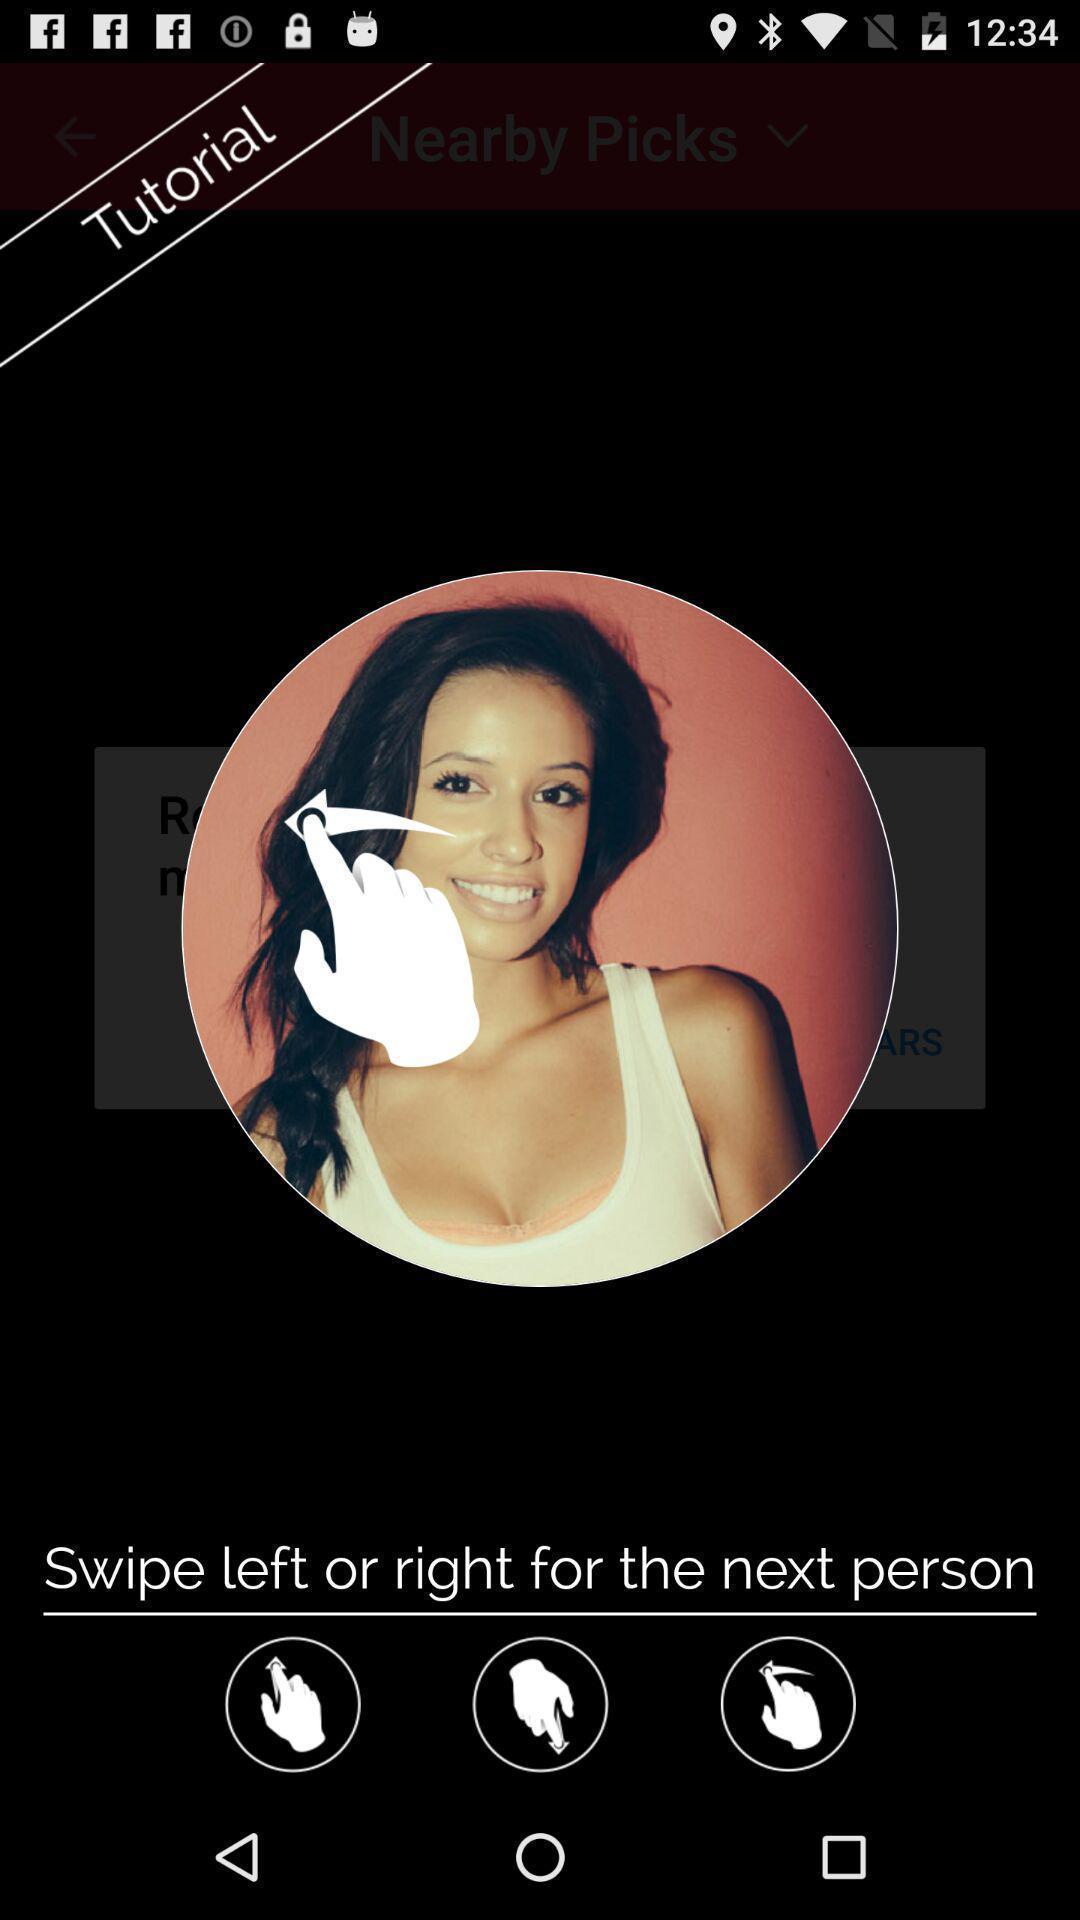Tell me what you see in this picture. Pop-up showing tips for using social app. 